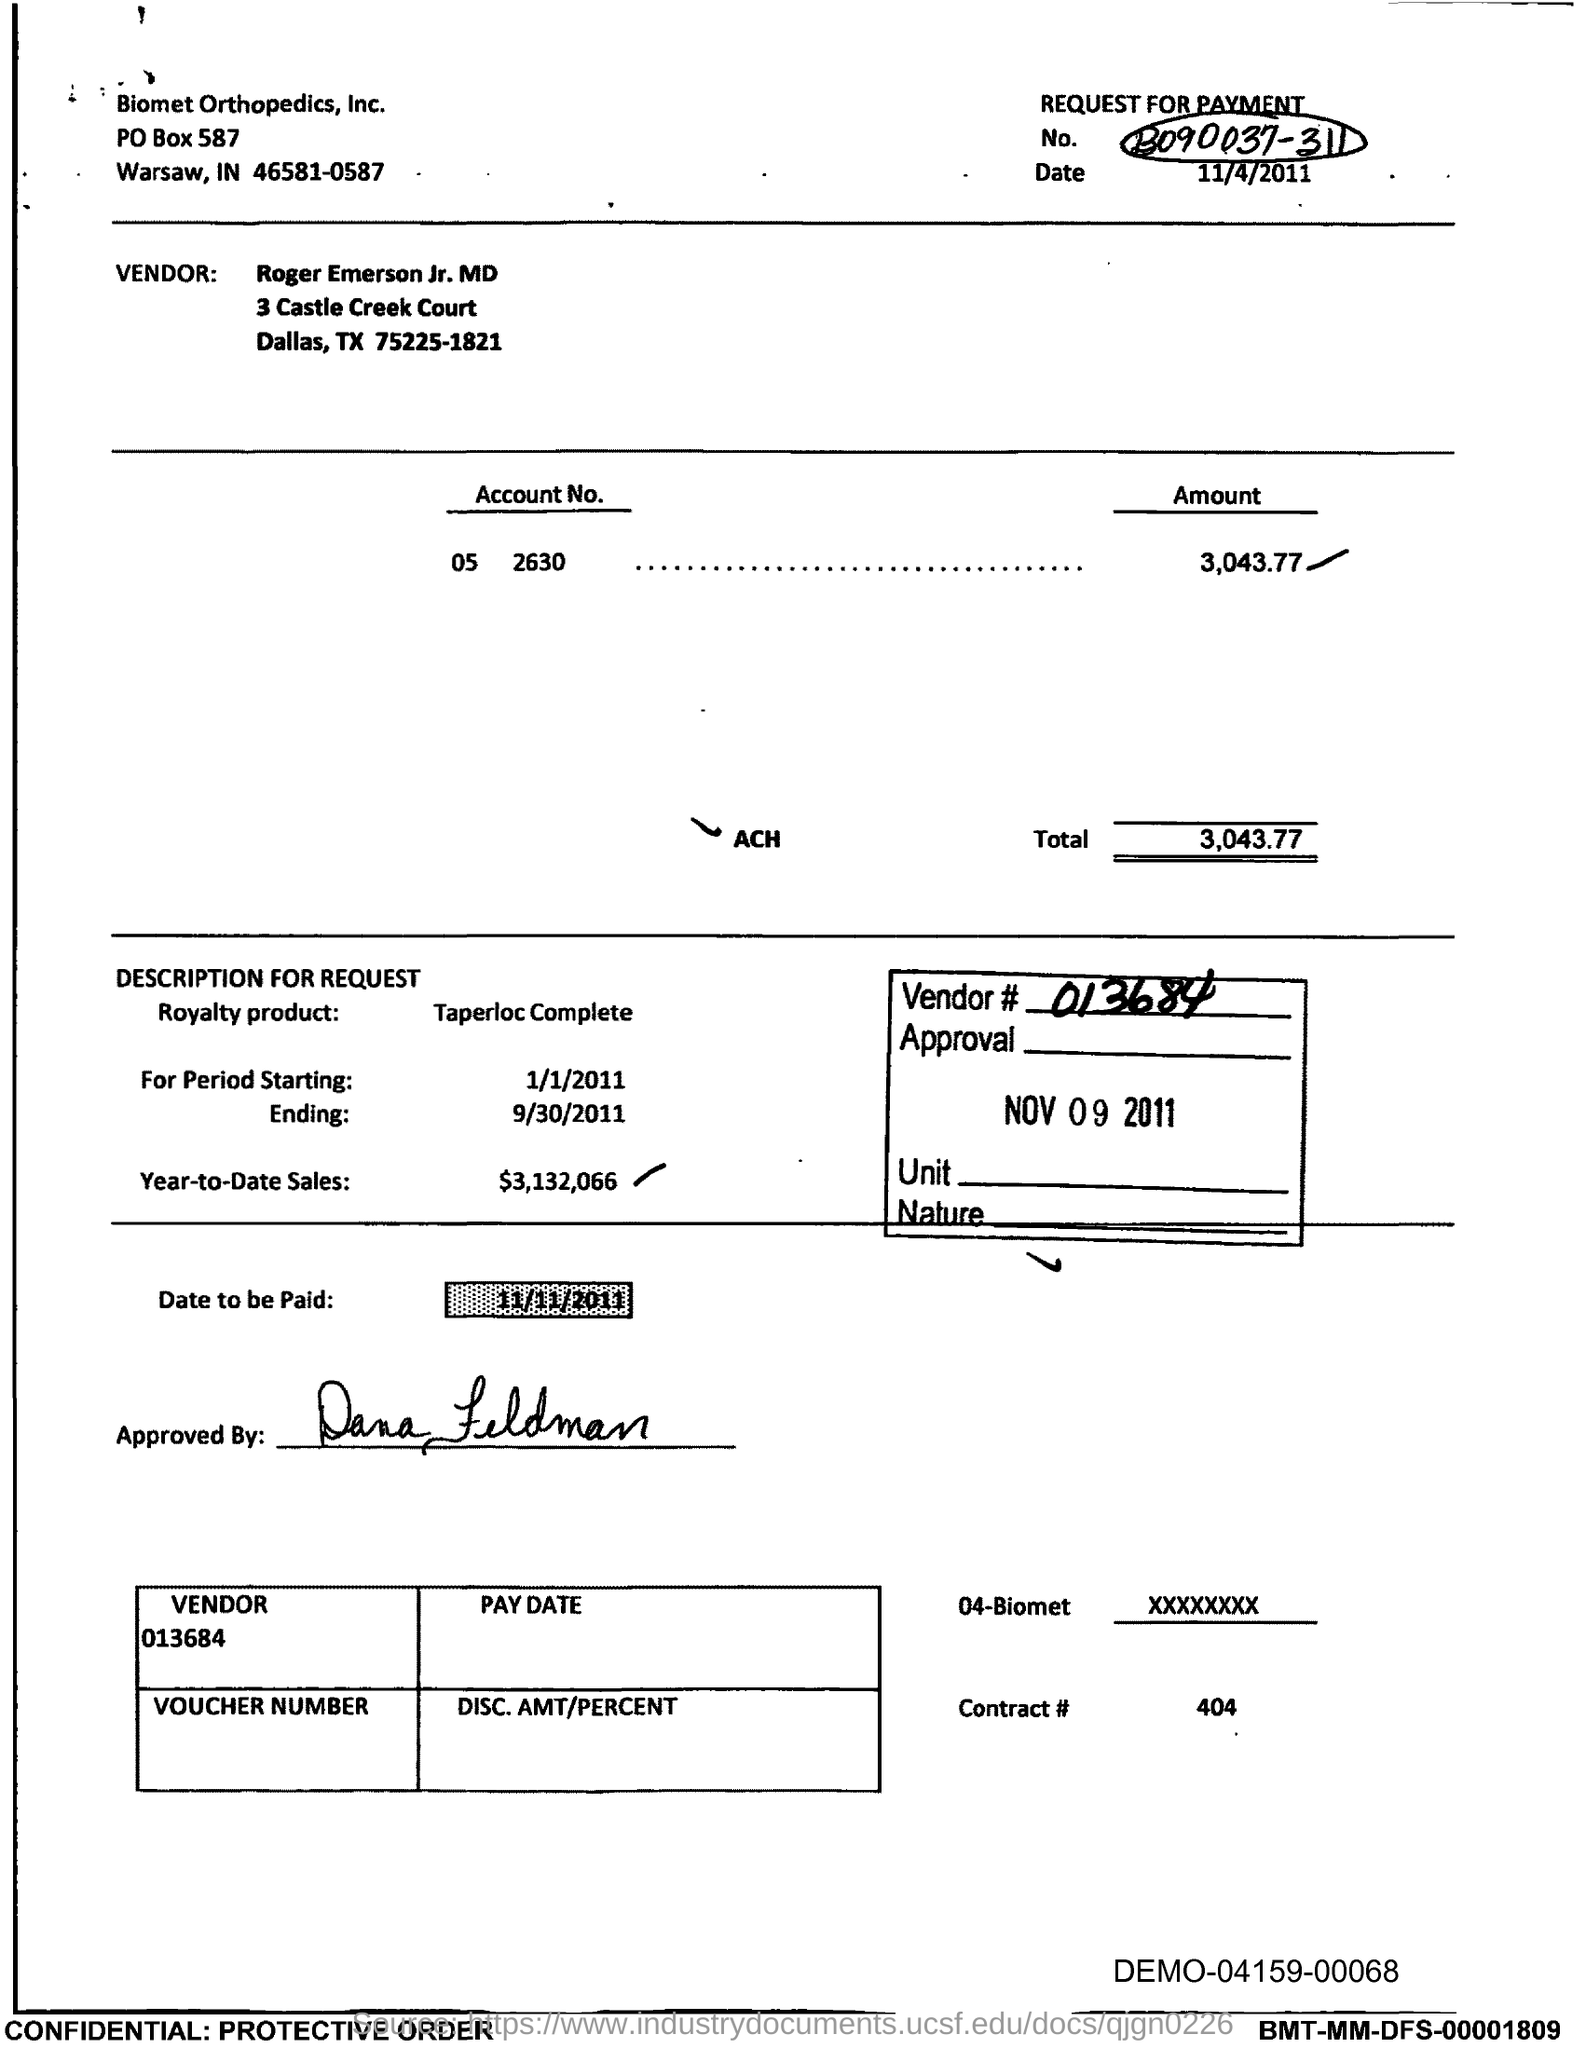What is the Account No. given in the document?
Your answer should be compact. 05 2630. What is the royalty product mentioned in the document?
Make the answer very short. Taperloc Complete. What is the Year-to-Date Sales of the royalty product?
Your answer should be very brief. $3,132,066. What is the vendor # given in the document?
Ensure brevity in your answer.  013684. What is the contract # mentioned in the document?
Offer a very short reply. 404. Which company is mentioned in the header of the document?
Offer a very short reply. Biomet orthopedics, inc. 